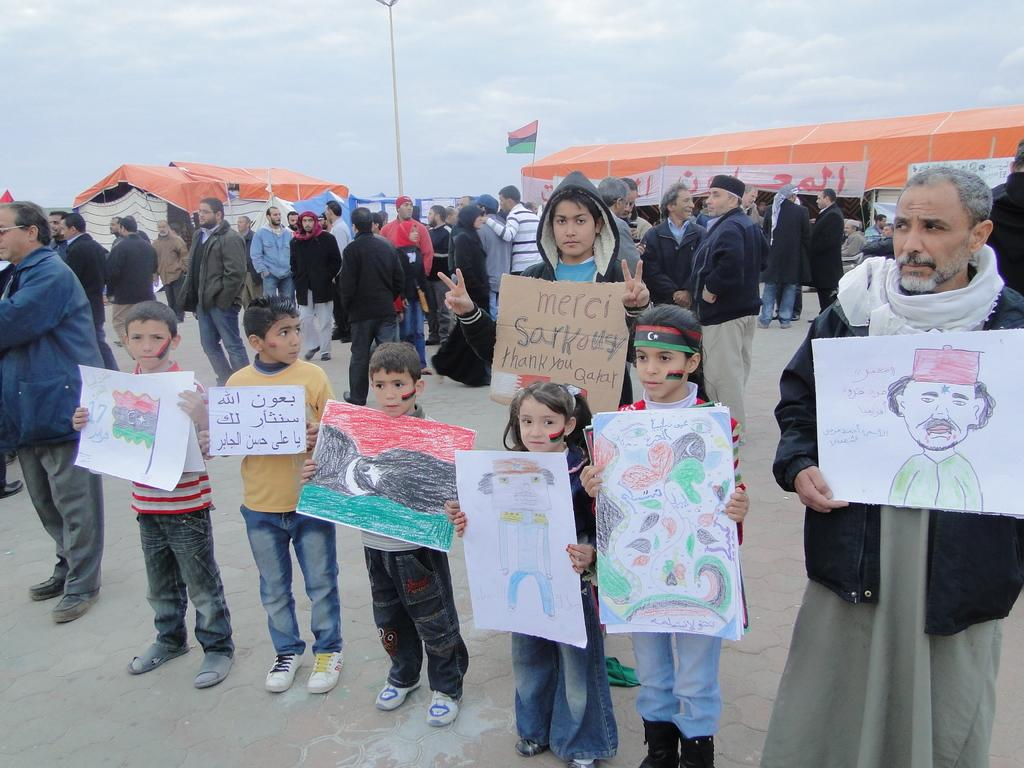How many people are in the image? There is a group of people standing in the image, but the exact number is not specified. What are some people holding in the image? Some people are holding papers in the image. What type of temporary shelters can be seen in the image? There are canopy tents in the image. What type of signage is present in the image? There are banners and a flag in the image. What can be seen in the background of the image? The sky is visible in the background of the image. Can you see any ghosts in the image? There are no ghosts present in the image. What type of tooth is visible in the image? There is no tooth present in the image. 